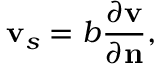<formula> <loc_0><loc_0><loc_500><loc_500>{ v } _ { s } = b \frac { \partial v } { \partial n } ,</formula> 